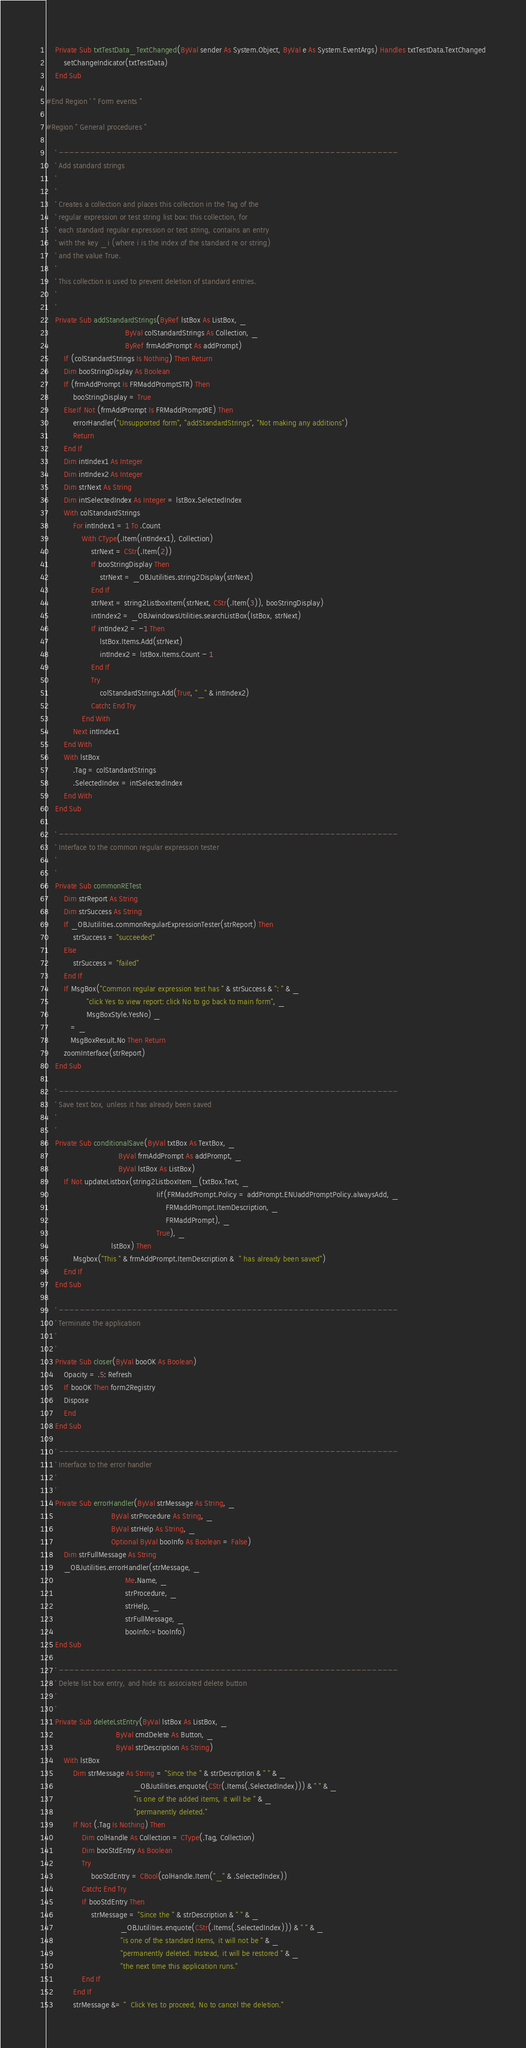Convert code to text. <code><loc_0><loc_0><loc_500><loc_500><_VisualBasic_>
    Private Sub txtTestData_TextChanged(ByVal sender As System.Object, ByVal e As System.EventArgs) Handles txtTestData.TextChanged
        setChangeIndicator(txtTestData)
    End Sub

#End Region ' " Form events "

#Region " General procedures "

    ' -----------------------------------------------------------------
    ' Add standard strings
    '
    '
    ' Creates a collection and places this collection in the Tag of the
    ' regular expression or test string list box: this collection, for 
    ' each standard regular expression or test string, contains an entry 
    ' with the key _i (where i is the index of the standard re or string) 
    ' and the value True.
    '
    ' This collection is used to prevent deletion of standard entries.
    '
    '
    Private Sub addStandardStrings(ByRef lstBox As ListBox, _
                                   ByVal colStandardStrings As Collection, _
                                   ByRef frmAddPrompt As addPrompt)
        If (colStandardStrings Is Nothing) Then Return
        Dim booStringDisplay As Boolean
        If (frmAddPrompt Is FRMaddPromptSTR) Then
            booStringDisplay = True
        ElseIf Not (frmAddPrompt Is FRMaddPromptRE) Then            
            errorHandler("Unsupported form", "addStandardStrings", "Not making any additions")
            Return
        End If        
        Dim intIndex1 As Integer
        Dim intIndex2 As Integer
        Dim strNext As String
        Dim intSelectedIndex As Integer = lstBox.SelectedIndex
        With colStandardStrings
            For intIndex1 = 1 To .Count
                With CType(.Item(intIndex1), Collection)
                    strNext = CStr(.Item(2))
                    If booStringDisplay Then
                        strNext = _OBJutilities.string2Display(strNext)
                    End If                    
                    strNext = string2ListboxItem(strNext, CStr(.Item(3)), booStringDisplay)
                    intIndex2 = _OBJwindowsUtilities.searchListBox(lstBox, strNext)
                    If intIndex2 = -1 Then
                        lstBox.Items.Add(strNext)
                        intIndex2 = lstBox.Items.Count - 1
                    End If     
                    Try
                        colStandardStrings.Add(True, "_" & intIndex2)
                    Catch: End Try                    
                End With           
            Next intIndex1     
        End With 
        With lstBox  
            .Tag = colStandardStrings
            .SelectedIndex = intSelectedIndex
        End With
    End Sub    
    
    ' -----------------------------------------------------------------
    ' Interface to the common regular expression tester
    '
    '
    Private Sub commonRETest
        Dim strReport As String
        Dim strSuccess As String
        If _OBJutilities.commonRegularExpressionTester(strReport) Then
            strSuccess = "succeeded"
        Else
            strSuccess = "failed"
        End If        
        If MsgBox("Common regular expression test has " & strSuccess & ": " & _
                  "click Yes to view report: click No to go back to main form", _
                  MsgBoxStyle.YesNo) _
           = _
           MsgBoxResult.No Then Return
        zoomInterface(strReport)                             
    End Sub    
    
    ' -----------------------------------------------------------------
    ' Save text box, unless it has already been saved
    '
    '
    Private Sub conditionalSave(ByVal txtBox As TextBox, _
                                ByVal frmAddPrompt As addPrompt, _
                                ByVal lstBox As ListBox)
        If Not updateListbox(string2ListboxItem_(txtBox.Text, _
                                                 Iif(FRMaddPrompt.Policy = addPrompt.ENUaddPromptPolicy.alwaysAdd, _
                                                     FRMaddPrompt.ItemDescription, _
                                                     FRMaddPrompt), _
                                                 True), _
                             lstBox) Then
            Msgbox("This " & frmAddPrompt.ItemDescription &  " has already been saved")
        End If                             
    End Sub    

    ' -----------------------------------------------------------------
    ' Terminate the application
    '
    '
    Private Sub closer(ByVal booOK As Boolean)
        Opacity = .5: Refresh
        If booOK Then form2Registry
        Dispose
        End
    End Sub

    ' -----------------------------------------------------------------
    ' Interface to the error handler
    '
    '
    Private Sub errorHandler(ByVal strMessage As String, _
                             ByVal strProcedure As String, _
                             ByVal strHelp As String, _
                             Optional ByVal booInfo As Boolean = False)
        Dim strFullMessage As String
        _OBJutilities.errorHandler(strMessage, _
                                   Me.Name, _
                                   strProcedure, _
                                   strHelp, _
                                   strFullMessage, _
                                   booInfo:=booInfo)
    End Sub
    
    ' -----------------------------------------------------------------
    ' Delete list box entry, and hide its associated delete button
    '
    '
    Private Sub deleteLstEntry(ByVal lstBox As ListBox, _
                               ByVal cmdDelete As Button, _
                               ByVal strDescription As String)
        With lstBox      
            Dim strMessage As String = "Since the " & strDescription & " " & _
                                       _OBJutilities.enquote(CStr(.Items(.SelectedIndex))) & " " & _
                                       "is one of the added items, it will be " & _
                                       "permanently deleted."   
            If Not (.Tag Is Nothing) Then
                Dim colHandle As Collection = CType(.Tag, Collection)
                Dim booStdEntry As Boolean  
                Try
                    booStdEntry = CBool(colHandle.Item("_" & .SelectedIndex))
                Catch: End Try                
                If booStdEntry Then
                    strMessage = "Since the " & strDescription & " " & _
                                 _OBJutilities.enquote(CStr(.Items(.SelectedIndex))) & " " & _
                                 "is one of the standard items, it will not be " & _
                                 "permanently deleted. Instead, it will be restored " & _
                                 "the next time this application runs."   
                End If   
            End If   
            strMessage &= "  Click Yes to proceed, No to cancel the deletion."                               </code> 